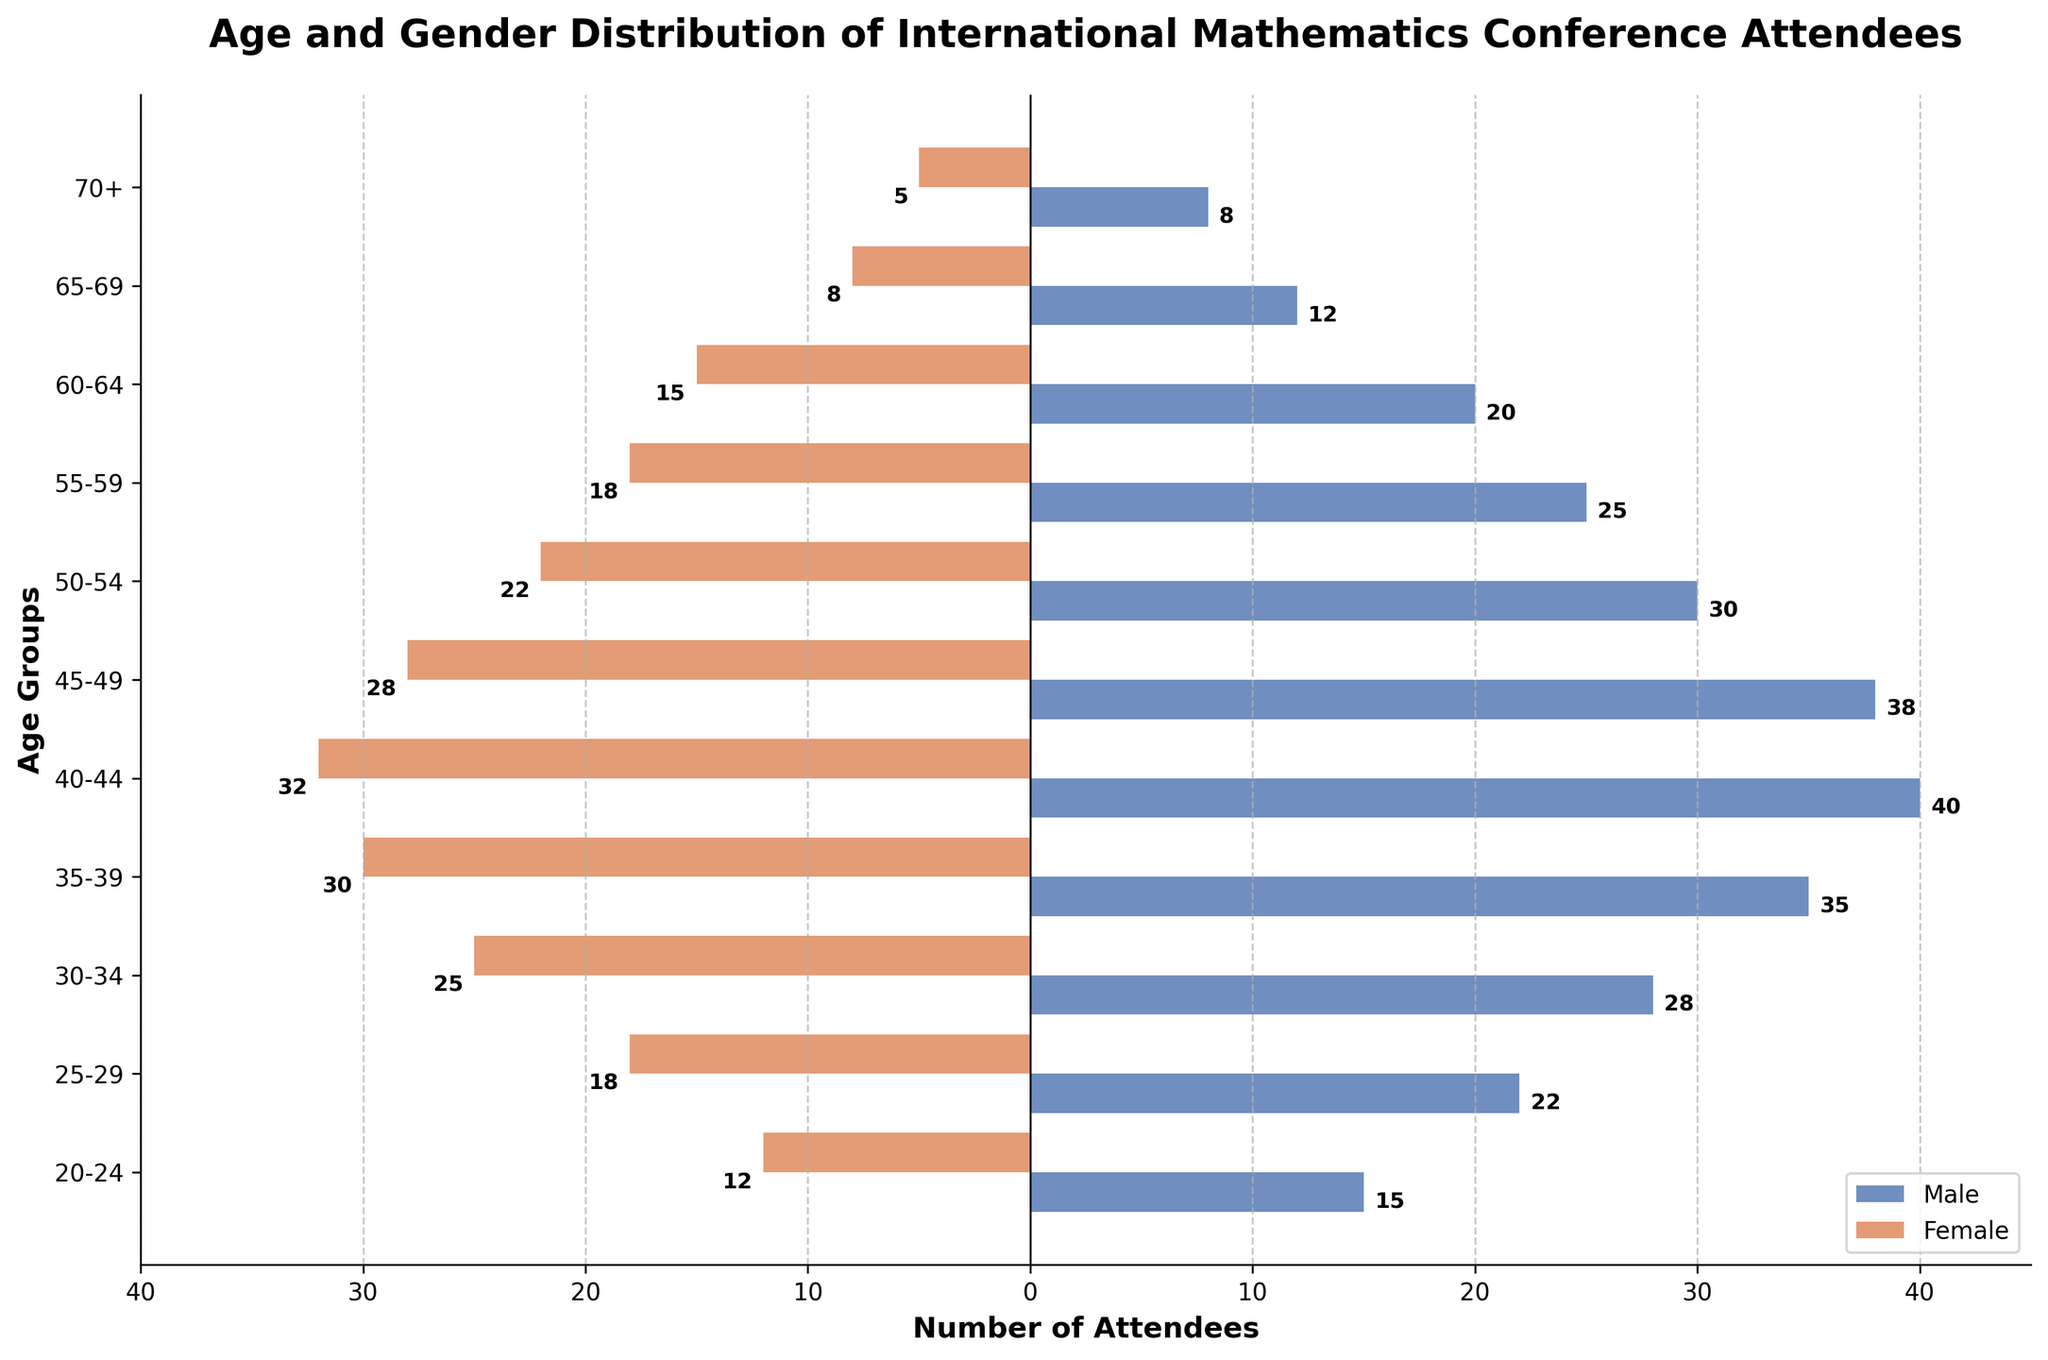what is the title of the figure? The title of the figure is typically found at the top of the chart in a larger and bolder font compared to other text elements. Here, the title "Age and Gender Distribution of International Mathematics Conference Attendees" is clearly visible and easily identifiable at the top of the chart.
Answer: Age and Gender Distribution of International Mathematics Conference Attendees What age group has the most male attendees? To find the age group with the most male attendees, look for the age group that has the longest bar extending to the right (since male values are positive). The age group 40-44 has the longest bar for male attendees, representing 40 individuals.
Answer: 40-44 What is the gender distribution in the 50-54 age group? In the 50-54 age group, look at the bars corresponding to "Male" and "Female". The male bar extends to the right, indicating 30 male attendees, and the female bar extends to the left, indicating 22 female attendees.
Answer: 30 males, 22 females Which nationality has the highest number of attendees in the 25-29 age range? The chart does not explicitly label nationalities by age group, but it is mentioned in the data provided. For the 25-29 age group, the nationality with the highest number of attendees is Germany, with 22 males and 18 females.
Answer: Germany How many more male attendees are there in the 35-39 age group than in the 55-59 age group? To find the difference, subtract the number of male attendees in the 55-59 age group from those in the 35-39 age group. There are 35 males in the 35-39 age group and 25 males in the 55-59 age group. So, 35 - 25 = 10.
Answer: 10 Is there any age group where female attendees outnumber male attendees? By observing the chart, note that female values are negative (bars extend to the left) and male values are positive (bars extend to the right). None of the age groups have female bars that are longer (more negative) than the corresponding male bars. Therefore, there is no age group where female attendees outnumber male attendees.
Answer: No What is the total number of attendees in the 40-44 age group? Calculate the total number of attendees by adding the number of males and females in the 40-44 age group. There are 40 males and 32 females. So, 40 + 32 = 72.
Answer: 72 How does the number of attendees in the 70+ age group compare to the 60-64 age group? Compare both the male and female attendees in the two age groups. For the 70+ age group, there are 8 males and 5 females (total 13), and for the 60-64 age group, there are 20 males and 15 females (total 35). So, the 60-64 age group has more attendees (35) compared to the 70+ age group (13).
Answer: 60-64 has more Which gender and age group combination has the smallest representation? The smallest representation can be found by locating the shortest bar for either gender across all age groups. The 70+ age group for females has the shortest bar, representing 5 individuals.
Answer: Female, 70+ 